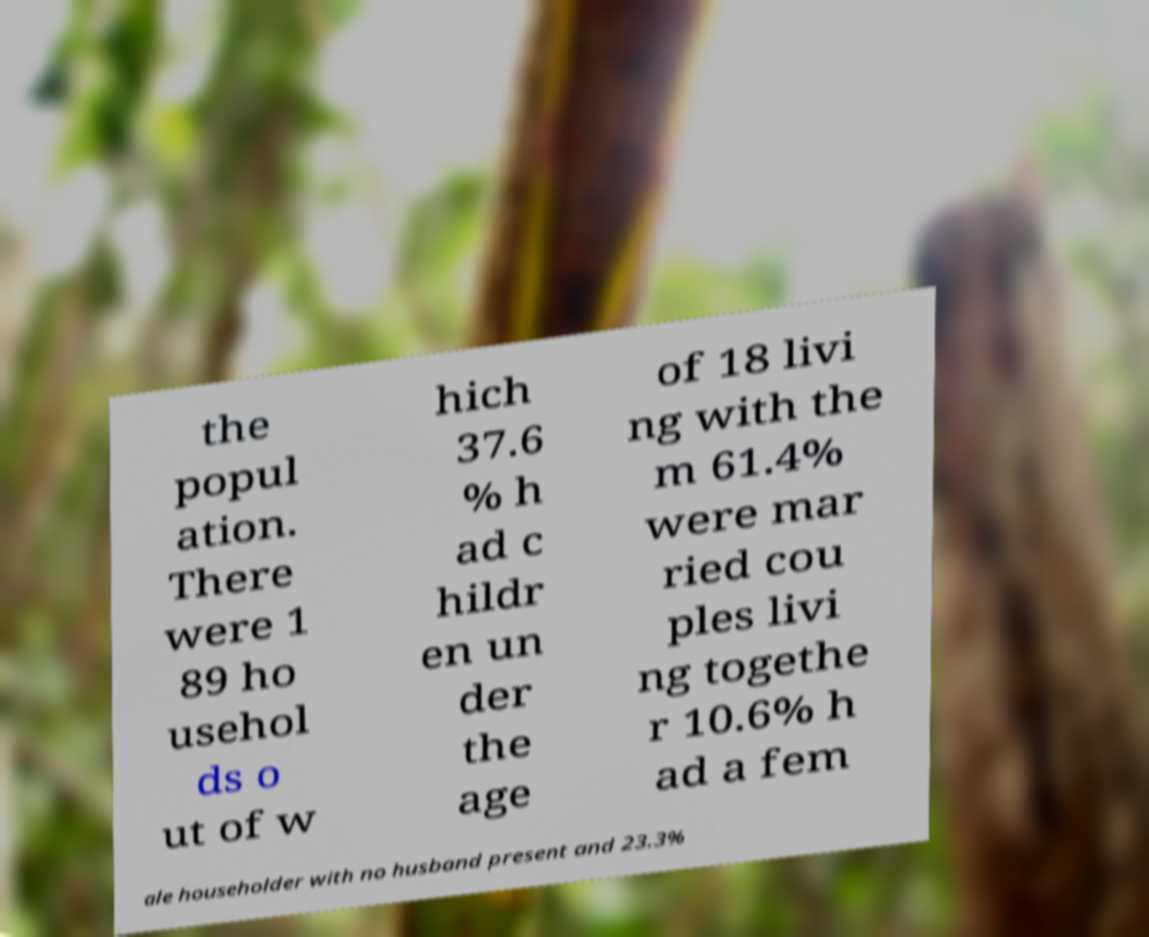Could you assist in decoding the text presented in this image and type it out clearly? the popul ation. There were 1 89 ho usehol ds o ut of w hich 37.6 % h ad c hildr en un der the age of 18 livi ng with the m 61.4% were mar ried cou ples livi ng togethe r 10.6% h ad a fem ale householder with no husband present and 23.3% 